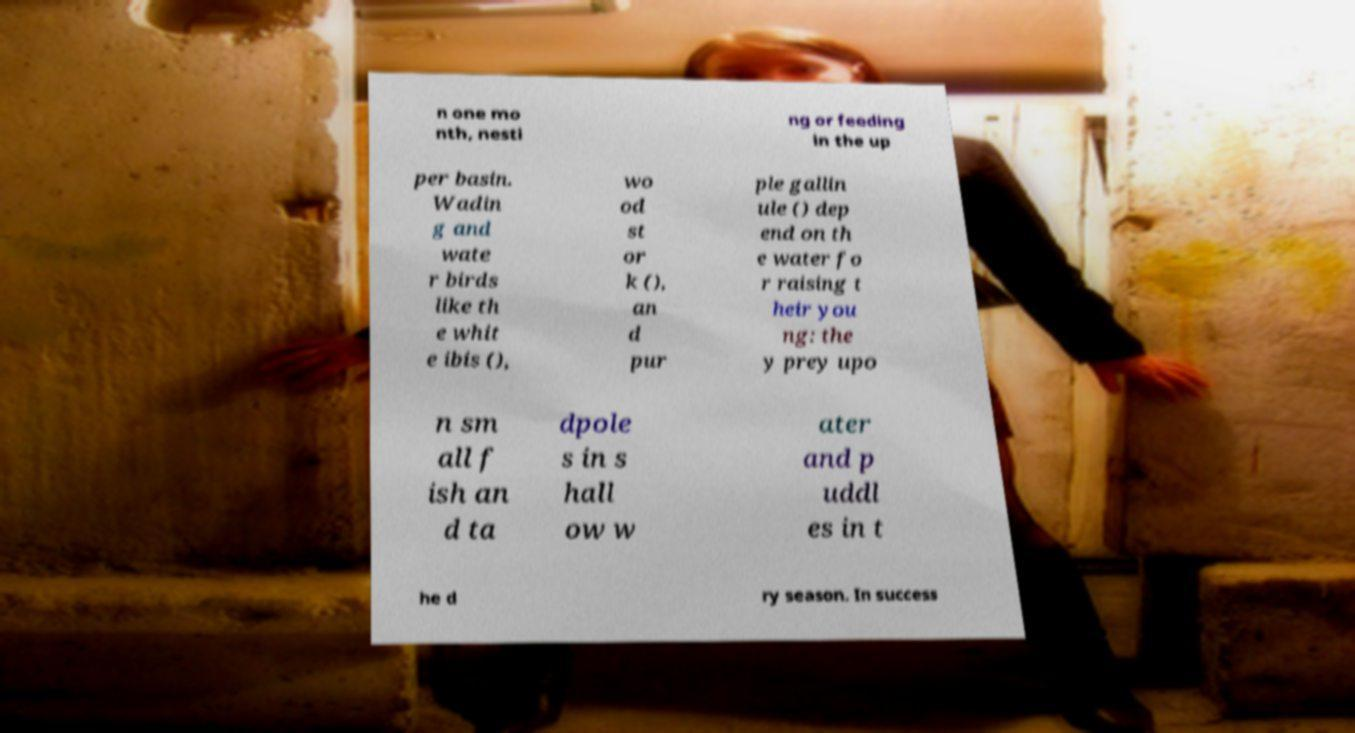I need the written content from this picture converted into text. Can you do that? n one mo nth, nesti ng or feeding in the up per basin. Wadin g and wate r birds like th e whit e ibis (), wo od st or k (), an d pur ple gallin ule () dep end on th e water fo r raising t heir you ng: the y prey upo n sm all f ish an d ta dpole s in s hall ow w ater and p uddl es in t he d ry season. In success 